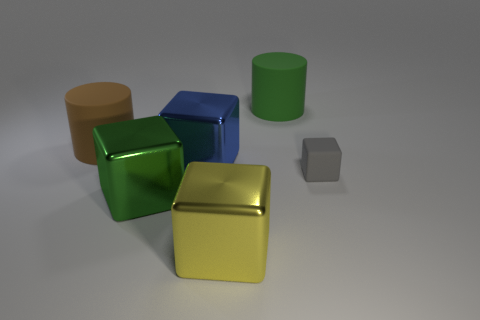What material is the cube behind the tiny rubber block?
Keep it short and to the point. Metal. Is the number of big green metallic objects greater than the number of cyan matte things?
Ensure brevity in your answer.  Yes. Do the green object that is in front of the gray object and the big brown rubber object have the same shape?
Provide a short and direct response. No. What number of rubber things are both right of the brown rubber object and left of the rubber block?
Give a very brief answer. 1. What number of other big green things are the same shape as the big green matte thing?
Provide a succinct answer. 0. There is a object that is in front of the big green thing on the left side of the blue cube; what color is it?
Offer a very short reply. Yellow. There is a tiny gray matte object; is its shape the same as the large green object behind the big brown cylinder?
Offer a terse response. No. There is a green thing behind the big block that is behind the shiny block that is on the left side of the large blue block; what is its material?
Make the answer very short. Rubber. Are there any green cubes of the same size as the blue cube?
Keep it short and to the point. Yes. There is a brown thing that is the same material as the gray cube; what size is it?
Provide a short and direct response. Large. 